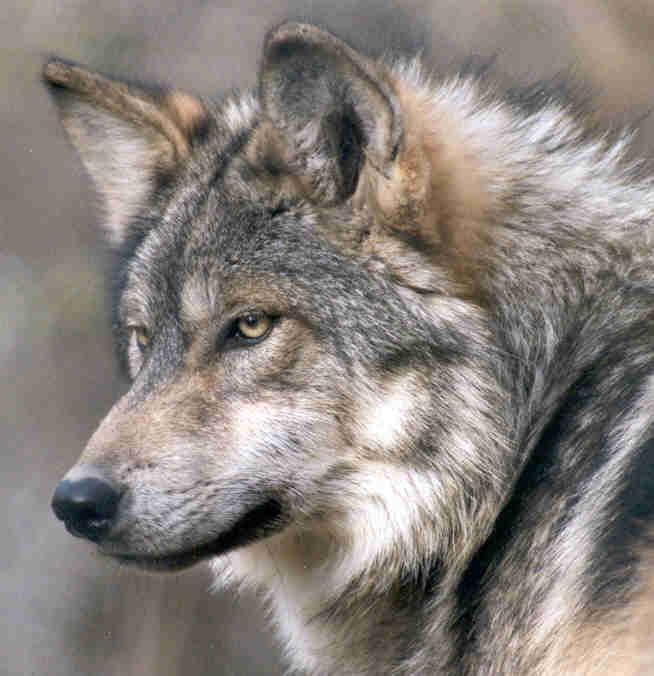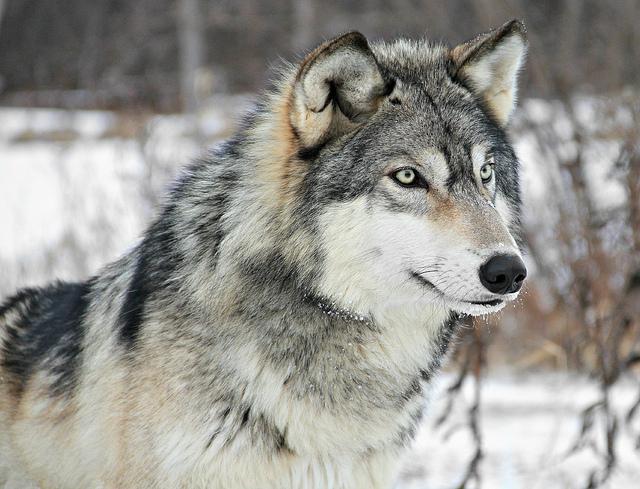The first image is the image on the left, the second image is the image on the right. Examine the images to the left and right. Is the description "the animal in the image on the right is facing right" accurate? Answer yes or no. Yes. The first image is the image on the left, the second image is the image on the right. Examine the images to the left and right. Is the description "One image shows a wolf in a snowy scene." accurate? Answer yes or no. Yes. The first image is the image on the left, the second image is the image on the right. Analyze the images presented: Is the assertion "There is one young wolf in one of the images." valid? Answer yes or no. No. 